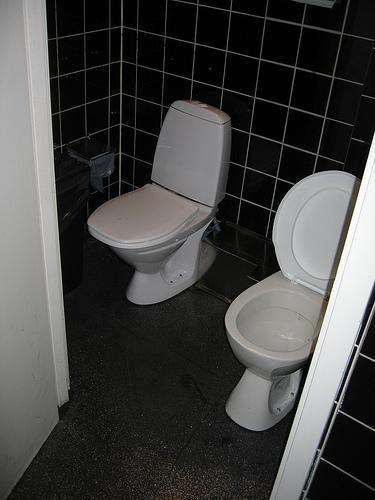How many toilets are there?
Give a very brief answer. 2. 